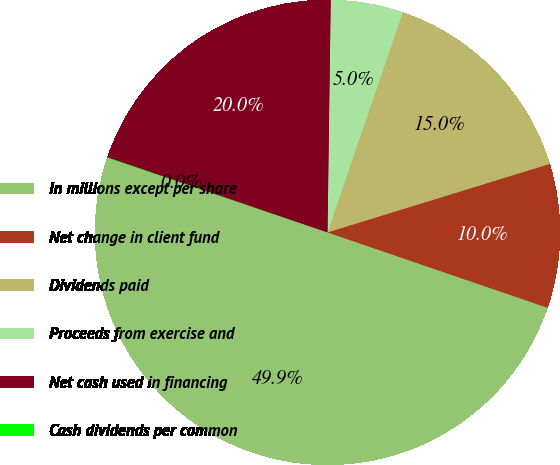Convert chart to OTSL. <chart><loc_0><loc_0><loc_500><loc_500><pie_chart><fcel>In millions except per share<fcel>Net change in client fund<fcel>Dividends paid<fcel>Proceeds from exercise and<fcel>Net cash used in financing<fcel>Cash dividends per common<nl><fcel>49.94%<fcel>10.01%<fcel>15.0%<fcel>5.02%<fcel>19.99%<fcel>0.03%<nl></chart> 